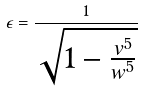<formula> <loc_0><loc_0><loc_500><loc_500>\epsilon = \frac { 1 } { \sqrt { 1 - \frac { v ^ { 5 } } { w ^ { 5 } } } }</formula> 